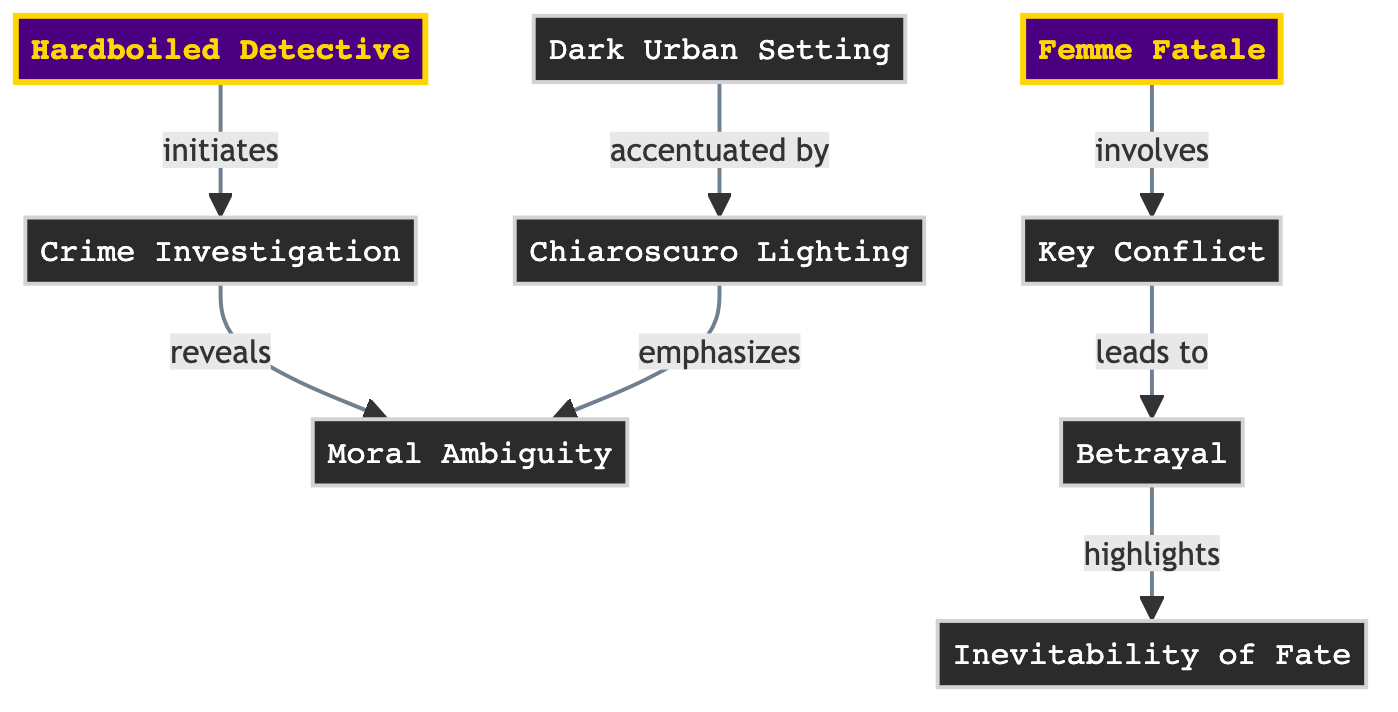What's the total number of nodes in the diagram? The diagram lists eight distinct entities, each representing a key characteristic or element of film noir. By counting each node shown in the provided data, we find they add up to a total of eight.
Answer: 8 What relationship does the "Hardboiled Detective" have with "Crime Investigation"? The directed edge from "Hardboiled Detective" to "Crime Investigation" is labeled "initiates," indicating that the hardboiled detective is the one who starts or triggers the crime investigation.
Answer: initiates Which node emphasizes "Moral Ambiguity"? The diagram shows that "Chiaroscuro Lighting" has a directed edge to "Moral Ambiguity," labeled "emphasizes." This indicates that the lighting style serves to highlight or draw attention to the moral ambiguity present in film noir.
Answer: Chiaroscuro Lighting What leads to the "Inevitability of Fate"? The edge directs from "Betrayal" to "Inevitability of Fate," labeled "highlights." This indicates that betrayal in the story emphasizes or points towards the themes of fate, suggesting a causal relationship where betrayal brings forth the concept of fate's inevitability.
Answer: Betrayal What characteristic is accentuated by "Dark Urban Setting"? The directed edge shows that "Dark Urban Setting" is connected to "Chiaroscuro Lighting," labeled "accentuated by." This means that the dark urban environment is enhanced or heightened by the use of chiaroscuro lighting techniques, which are prevalent in film noir styling.
Answer: Chiaroscuro Lighting How many edges exist in the diagram? To determine the number of edges, we count the directed relationships between the nodes, which are defined in the provided data. There are a total of six connections between the various nodes in the diagram.
Answer: 6 What does "Crime Investigation" reveal? The directed edge points from "Crime Investigation" to "Moral Ambiguity," with the label "reveals." This relationship indicates that the investigation process uncovers or brings to light the moral ambiguity that is a critical component of film noir narratives.
Answer: Moral Ambiguity What does "Key Conflict" lead to? The edge from "Key Conflict" to "Betrayal" is labeled "leads to." This relationship suggests that the primary conflict in the narrative between characters or forces will ultimately result in betrayal, a common theme in noir films.
Answer: Betrayal 